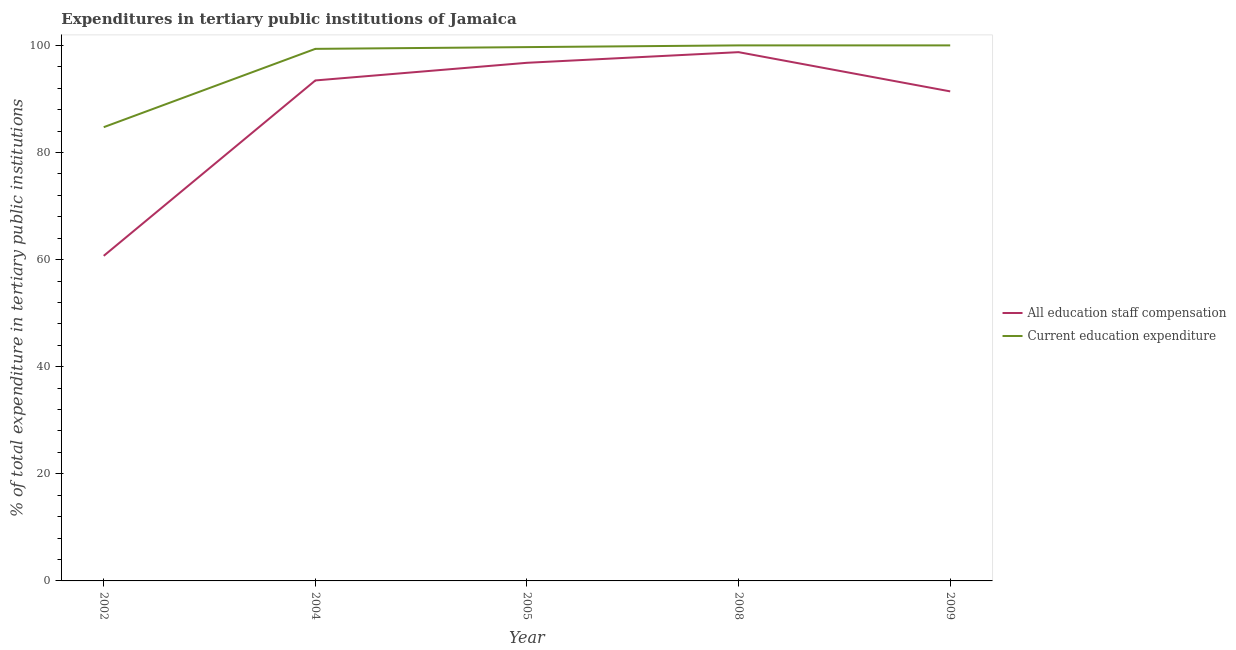How many different coloured lines are there?
Make the answer very short. 2. Does the line corresponding to expenditure in education intersect with the line corresponding to expenditure in staff compensation?
Provide a succinct answer. No. Is the number of lines equal to the number of legend labels?
Provide a short and direct response. Yes. What is the expenditure in staff compensation in 2004?
Offer a terse response. 93.46. Across all years, what is the maximum expenditure in staff compensation?
Your answer should be compact. 98.74. Across all years, what is the minimum expenditure in education?
Offer a very short reply. 84.73. What is the total expenditure in staff compensation in the graph?
Your response must be concise. 441.06. What is the difference between the expenditure in education in 2002 and that in 2009?
Keep it short and to the point. -15.27. What is the difference between the expenditure in education in 2004 and the expenditure in staff compensation in 2002?
Give a very brief answer. 38.65. What is the average expenditure in staff compensation per year?
Provide a short and direct response. 88.21. In the year 2005, what is the difference between the expenditure in education and expenditure in staff compensation?
Keep it short and to the point. 2.93. In how many years, is the expenditure in education greater than 32 %?
Your answer should be compact. 5. What is the ratio of the expenditure in education in 2005 to that in 2009?
Make the answer very short. 1. Is the expenditure in education in 2002 less than that in 2004?
Offer a terse response. Yes. Is the difference between the expenditure in education in 2002 and 2004 greater than the difference between the expenditure in staff compensation in 2002 and 2004?
Offer a very short reply. Yes. What is the difference between the highest and the second highest expenditure in staff compensation?
Provide a succinct answer. 1.99. What is the difference between the highest and the lowest expenditure in education?
Ensure brevity in your answer.  15.27. Is the sum of the expenditure in education in 2004 and 2005 greater than the maximum expenditure in staff compensation across all years?
Ensure brevity in your answer.  Yes. How many years are there in the graph?
Provide a short and direct response. 5. What is the difference between two consecutive major ticks on the Y-axis?
Offer a terse response. 20. Does the graph contain any zero values?
Your answer should be compact. No. How are the legend labels stacked?
Your response must be concise. Vertical. What is the title of the graph?
Ensure brevity in your answer.  Expenditures in tertiary public institutions of Jamaica. Does "GDP" appear as one of the legend labels in the graph?
Give a very brief answer. No. What is the label or title of the Y-axis?
Offer a very short reply. % of total expenditure in tertiary public institutions. What is the % of total expenditure in tertiary public institutions in All education staff compensation in 2002?
Make the answer very short. 60.7. What is the % of total expenditure in tertiary public institutions in Current education expenditure in 2002?
Offer a very short reply. 84.73. What is the % of total expenditure in tertiary public institutions in All education staff compensation in 2004?
Give a very brief answer. 93.46. What is the % of total expenditure in tertiary public institutions of Current education expenditure in 2004?
Keep it short and to the point. 99.35. What is the % of total expenditure in tertiary public institutions of All education staff compensation in 2005?
Your answer should be very brief. 96.75. What is the % of total expenditure in tertiary public institutions of Current education expenditure in 2005?
Your response must be concise. 99.68. What is the % of total expenditure in tertiary public institutions in All education staff compensation in 2008?
Ensure brevity in your answer.  98.74. What is the % of total expenditure in tertiary public institutions in Current education expenditure in 2008?
Your response must be concise. 100. What is the % of total expenditure in tertiary public institutions of All education staff compensation in 2009?
Give a very brief answer. 91.41. Across all years, what is the maximum % of total expenditure in tertiary public institutions in All education staff compensation?
Give a very brief answer. 98.74. Across all years, what is the maximum % of total expenditure in tertiary public institutions in Current education expenditure?
Your response must be concise. 100. Across all years, what is the minimum % of total expenditure in tertiary public institutions in All education staff compensation?
Offer a very short reply. 60.7. Across all years, what is the minimum % of total expenditure in tertiary public institutions of Current education expenditure?
Keep it short and to the point. 84.73. What is the total % of total expenditure in tertiary public institutions of All education staff compensation in the graph?
Your answer should be very brief. 441.06. What is the total % of total expenditure in tertiary public institutions in Current education expenditure in the graph?
Ensure brevity in your answer.  483.77. What is the difference between the % of total expenditure in tertiary public institutions in All education staff compensation in 2002 and that in 2004?
Ensure brevity in your answer.  -32.75. What is the difference between the % of total expenditure in tertiary public institutions of Current education expenditure in 2002 and that in 2004?
Your answer should be compact. -14.62. What is the difference between the % of total expenditure in tertiary public institutions of All education staff compensation in 2002 and that in 2005?
Your response must be concise. -36.05. What is the difference between the % of total expenditure in tertiary public institutions in Current education expenditure in 2002 and that in 2005?
Ensure brevity in your answer.  -14.95. What is the difference between the % of total expenditure in tertiary public institutions in All education staff compensation in 2002 and that in 2008?
Make the answer very short. -38.04. What is the difference between the % of total expenditure in tertiary public institutions in Current education expenditure in 2002 and that in 2008?
Your response must be concise. -15.27. What is the difference between the % of total expenditure in tertiary public institutions of All education staff compensation in 2002 and that in 2009?
Give a very brief answer. -30.71. What is the difference between the % of total expenditure in tertiary public institutions in Current education expenditure in 2002 and that in 2009?
Your response must be concise. -15.27. What is the difference between the % of total expenditure in tertiary public institutions in All education staff compensation in 2004 and that in 2005?
Offer a very short reply. -3.3. What is the difference between the % of total expenditure in tertiary public institutions in Current education expenditure in 2004 and that in 2005?
Make the answer very short. -0.33. What is the difference between the % of total expenditure in tertiary public institutions in All education staff compensation in 2004 and that in 2008?
Your answer should be compact. -5.28. What is the difference between the % of total expenditure in tertiary public institutions in Current education expenditure in 2004 and that in 2008?
Your response must be concise. -0.65. What is the difference between the % of total expenditure in tertiary public institutions of All education staff compensation in 2004 and that in 2009?
Offer a terse response. 2.04. What is the difference between the % of total expenditure in tertiary public institutions of Current education expenditure in 2004 and that in 2009?
Offer a terse response. -0.65. What is the difference between the % of total expenditure in tertiary public institutions in All education staff compensation in 2005 and that in 2008?
Provide a succinct answer. -1.99. What is the difference between the % of total expenditure in tertiary public institutions of Current education expenditure in 2005 and that in 2008?
Keep it short and to the point. -0.32. What is the difference between the % of total expenditure in tertiary public institutions of All education staff compensation in 2005 and that in 2009?
Keep it short and to the point. 5.34. What is the difference between the % of total expenditure in tertiary public institutions in Current education expenditure in 2005 and that in 2009?
Keep it short and to the point. -0.32. What is the difference between the % of total expenditure in tertiary public institutions of All education staff compensation in 2008 and that in 2009?
Ensure brevity in your answer.  7.32. What is the difference between the % of total expenditure in tertiary public institutions of All education staff compensation in 2002 and the % of total expenditure in tertiary public institutions of Current education expenditure in 2004?
Your response must be concise. -38.65. What is the difference between the % of total expenditure in tertiary public institutions of All education staff compensation in 2002 and the % of total expenditure in tertiary public institutions of Current education expenditure in 2005?
Give a very brief answer. -38.98. What is the difference between the % of total expenditure in tertiary public institutions of All education staff compensation in 2002 and the % of total expenditure in tertiary public institutions of Current education expenditure in 2008?
Your answer should be compact. -39.3. What is the difference between the % of total expenditure in tertiary public institutions in All education staff compensation in 2002 and the % of total expenditure in tertiary public institutions in Current education expenditure in 2009?
Keep it short and to the point. -39.3. What is the difference between the % of total expenditure in tertiary public institutions of All education staff compensation in 2004 and the % of total expenditure in tertiary public institutions of Current education expenditure in 2005?
Provide a succinct answer. -6.23. What is the difference between the % of total expenditure in tertiary public institutions in All education staff compensation in 2004 and the % of total expenditure in tertiary public institutions in Current education expenditure in 2008?
Make the answer very short. -6.54. What is the difference between the % of total expenditure in tertiary public institutions in All education staff compensation in 2004 and the % of total expenditure in tertiary public institutions in Current education expenditure in 2009?
Ensure brevity in your answer.  -6.54. What is the difference between the % of total expenditure in tertiary public institutions of All education staff compensation in 2005 and the % of total expenditure in tertiary public institutions of Current education expenditure in 2008?
Keep it short and to the point. -3.25. What is the difference between the % of total expenditure in tertiary public institutions of All education staff compensation in 2005 and the % of total expenditure in tertiary public institutions of Current education expenditure in 2009?
Give a very brief answer. -3.25. What is the difference between the % of total expenditure in tertiary public institutions of All education staff compensation in 2008 and the % of total expenditure in tertiary public institutions of Current education expenditure in 2009?
Offer a terse response. -1.26. What is the average % of total expenditure in tertiary public institutions in All education staff compensation per year?
Your response must be concise. 88.21. What is the average % of total expenditure in tertiary public institutions of Current education expenditure per year?
Ensure brevity in your answer.  96.75. In the year 2002, what is the difference between the % of total expenditure in tertiary public institutions in All education staff compensation and % of total expenditure in tertiary public institutions in Current education expenditure?
Your answer should be compact. -24.03. In the year 2004, what is the difference between the % of total expenditure in tertiary public institutions in All education staff compensation and % of total expenditure in tertiary public institutions in Current education expenditure?
Your answer should be compact. -5.9. In the year 2005, what is the difference between the % of total expenditure in tertiary public institutions in All education staff compensation and % of total expenditure in tertiary public institutions in Current education expenditure?
Give a very brief answer. -2.93. In the year 2008, what is the difference between the % of total expenditure in tertiary public institutions of All education staff compensation and % of total expenditure in tertiary public institutions of Current education expenditure?
Make the answer very short. -1.26. In the year 2009, what is the difference between the % of total expenditure in tertiary public institutions of All education staff compensation and % of total expenditure in tertiary public institutions of Current education expenditure?
Keep it short and to the point. -8.59. What is the ratio of the % of total expenditure in tertiary public institutions in All education staff compensation in 2002 to that in 2004?
Give a very brief answer. 0.65. What is the ratio of the % of total expenditure in tertiary public institutions of Current education expenditure in 2002 to that in 2004?
Your response must be concise. 0.85. What is the ratio of the % of total expenditure in tertiary public institutions of All education staff compensation in 2002 to that in 2005?
Your answer should be very brief. 0.63. What is the ratio of the % of total expenditure in tertiary public institutions of Current education expenditure in 2002 to that in 2005?
Ensure brevity in your answer.  0.85. What is the ratio of the % of total expenditure in tertiary public institutions in All education staff compensation in 2002 to that in 2008?
Your answer should be compact. 0.61. What is the ratio of the % of total expenditure in tertiary public institutions of Current education expenditure in 2002 to that in 2008?
Make the answer very short. 0.85. What is the ratio of the % of total expenditure in tertiary public institutions in All education staff compensation in 2002 to that in 2009?
Provide a succinct answer. 0.66. What is the ratio of the % of total expenditure in tertiary public institutions in Current education expenditure in 2002 to that in 2009?
Offer a terse response. 0.85. What is the ratio of the % of total expenditure in tertiary public institutions of All education staff compensation in 2004 to that in 2005?
Offer a very short reply. 0.97. What is the ratio of the % of total expenditure in tertiary public institutions of Current education expenditure in 2004 to that in 2005?
Your answer should be compact. 1. What is the ratio of the % of total expenditure in tertiary public institutions in All education staff compensation in 2004 to that in 2008?
Ensure brevity in your answer.  0.95. What is the ratio of the % of total expenditure in tertiary public institutions of All education staff compensation in 2004 to that in 2009?
Offer a very short reply. 1.02. What is the ratio of the % of total expenditure in tertiary public institutions of All education staff compensation in 2005 to that in 2008?
Give a very brief answer. 0.98. What is the ratio of the % of total expenditure in tertiary public institutions of Current education expenditure in 2005 to that in 2008?
Make the answer very short. 1. What is the ratio of the % of total expenditure in tertiary public institutions in All education staff compensation in 2005 to that in 2009?
Your answer should be compact. 1.06. What is the ratio of the % of total expenditure in tertiary public institutions in Current education expenditure in 2005 to that in 2009?
Keep it short and to the point. 1. What is the ratio of the % of total expenditure in tertiary public institutions of All education staff compensation in 2008 to that in 2009?
Provide a succinct answer. 1.08. What is the ratio of the % of total expenditure in tertiary public institutions of Current education expenditure in 2008 to that in 2009?
Offer a very short reply. 1. What is the difference between the highest and the second highest % of total expenditure in tertiary public institutions of All education staff compensation?
Provide a succinct answer. 1.99. What is the difference between the highest and the lowest % of total expenditure in tertiary public institutions in All education staff compensation?
Make the answer very short. 38.04. What is the difference between the highest and the lowest % of total expenditure in tertiary public institutions in Current education expenditure?
Provide a succinct answer. 15.27. 